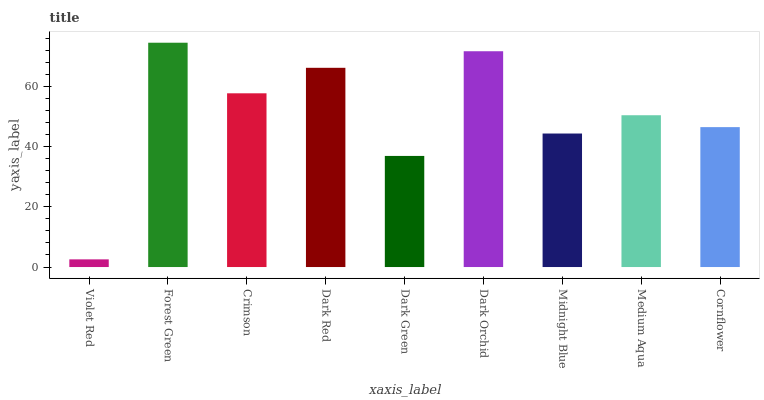Is Violet Red the minimum?
Answer yes or no. Yes. Is Forest Green the maximum?
Answer yes or no. Yes. Is Crimson the minimum?
Answer yes or no. No. Is Crimson the maximum?
Answer yes or no. No. Is Forest Green greater than Crimson?
Answer yes or no. Yes. Is Crimson less than Forest Green?
Answer yes or no. Yes. Is Crimson greater than Forest Green?
Answer yes or no. No. Is Forest Green less than Crimson?
Answer yes or no. No. Is Medium Aqua the high median?
Answer yes or no. Yes. Is Medium Aqua the low median?
Answer yes or no. Yes. Is Dark Orchid the high median?
Answer yes or no. No. Is Violet Red the low median?
Answer yes or no. No. 